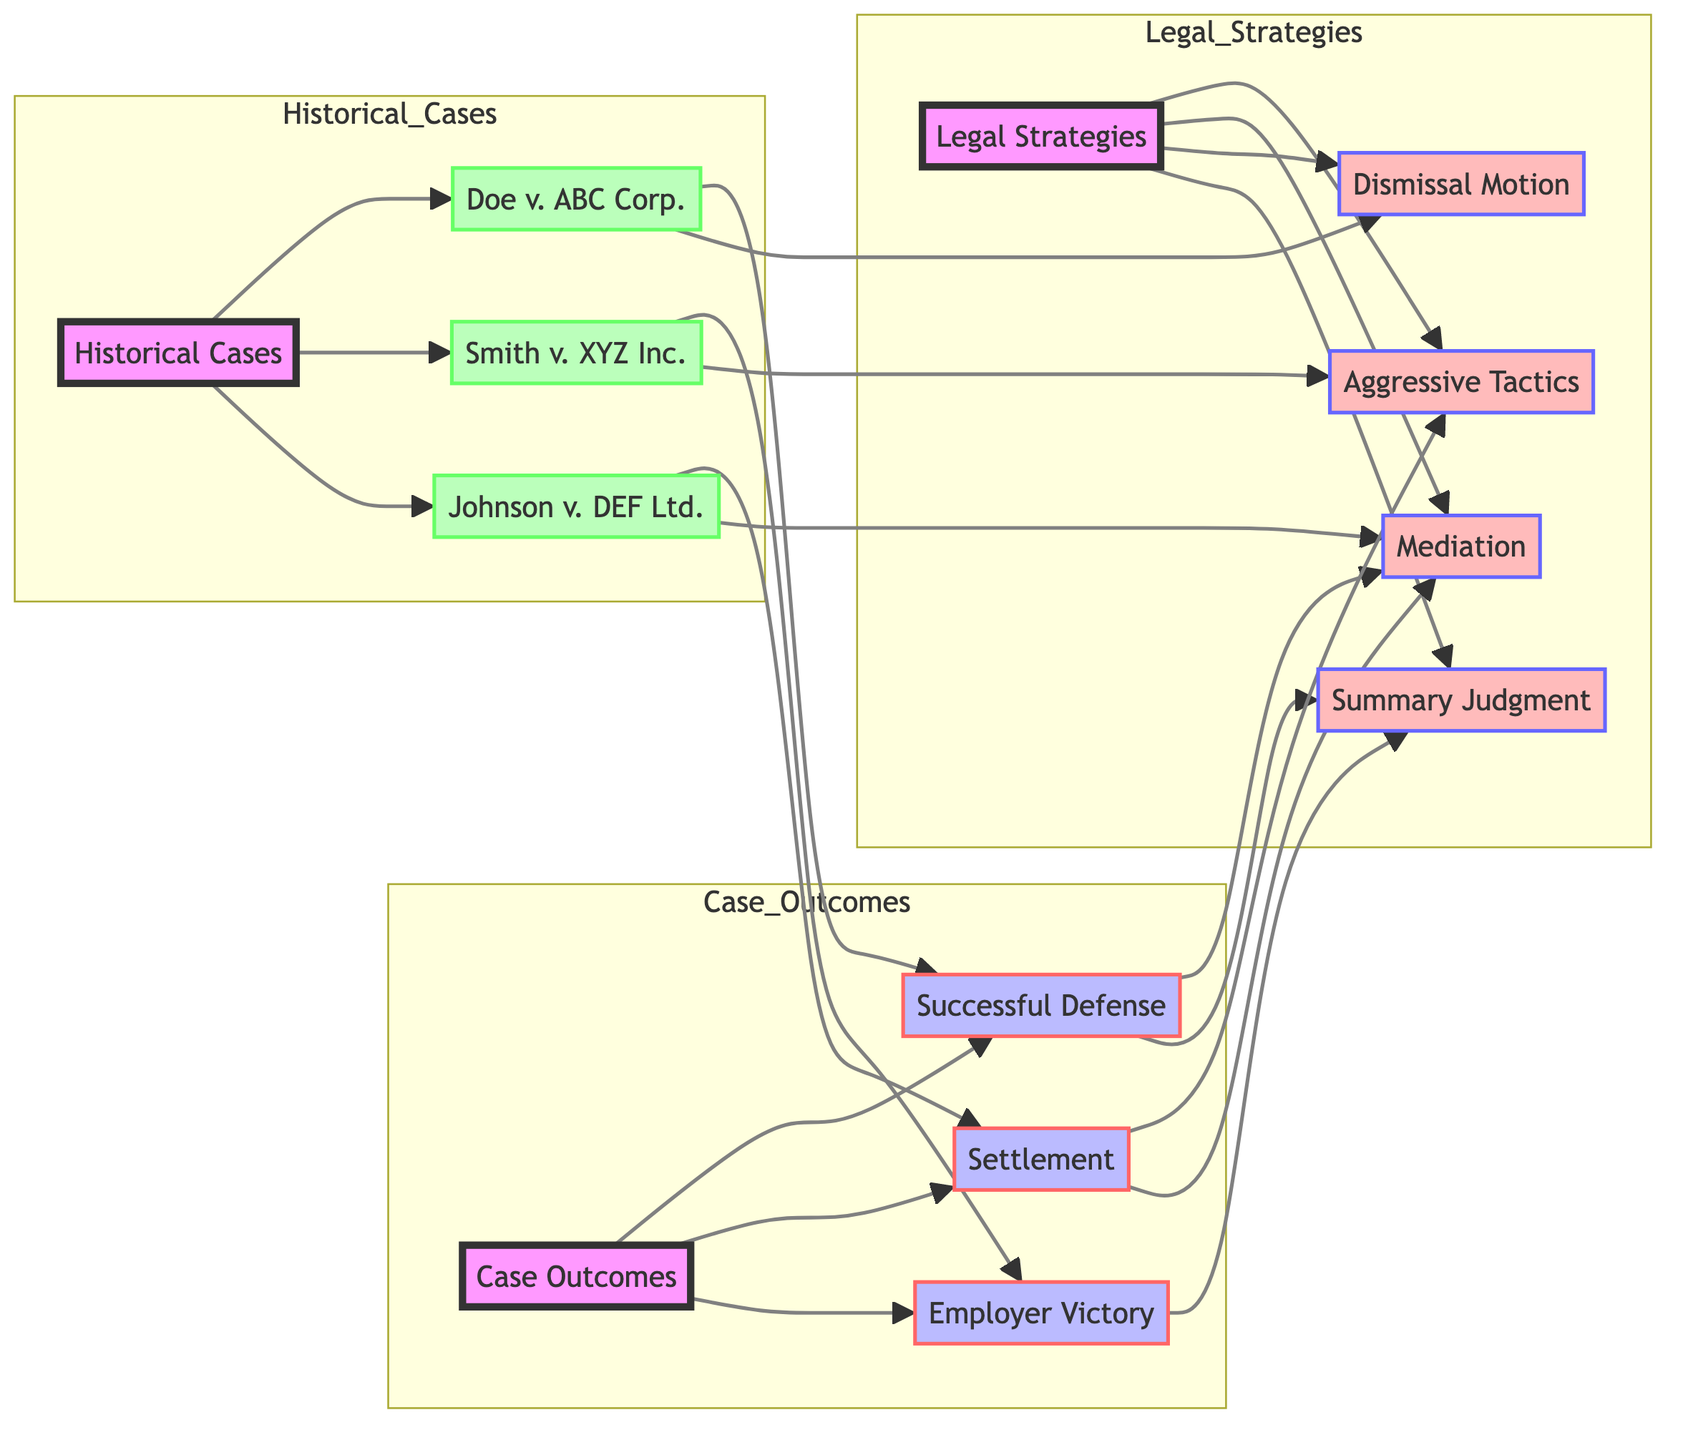What are the three case outcomes represented in the diagram? The diagram shows three case outcomes: Successful Defense, Settlement, and Employer Victory, all of which are part of the Case Outcomes category.
Answer: Successful Defense, Settlement, Employer Victory How many legal strategies are depicted in the network? There are four legal strategies shown in the diagram: Aggressive Tactics, Mediation, Dismissal Motion, and Summary Judgment under the Legal Strategies category, making a total of four.
Answer: 4 Which case resulted in a Settlement? The case Johnson v. DEF Ltd. resulted in a Settlement, as indicated by the direction from the case node to the case outcome node.
Answer: Johnson v. DEF Ltd Which strategies are employed in the case Doe v. ABC Corp.? The case Doe v. ABC Corp. employed the Dismissal Motion strategy, as shown by the direct link between the case node and the strategy node.
Answer: Dismissal Motion What legal strategy is associated with Successful Defense? Successful Defense is associated with both Mediation and Summary Judgment strategies, providing pathways from Successful Defense to these strategies in the diagram.
Answer: Mediation, Summary Judgment How many edges connect the Case Outcomes to the outcomes listed? There are three edges that connect the Case Outcomes category to the outcomes listed: Successful Defense, Settlement, and Employer Victory, meaning three direct connections.
Answer: 3 Which historical case employed Aggressive Tactics? The historical case Smith v. XYZ Inc. employed Aggressive Tactics as indicated by the link from this case to the strategy node for Aggressive Tactics.
Answer: Smith v. XYZ Inc What type of relationship exists between Settlement and Aggressive Tactics? The relationship between Settlement and Aggressive Tactics is classified as "associated_with," indicating a link connecting the two concepts in the diagram.
Answer: associated_with Which two case outcomes are associated with the Summary Judgment strategy? Summary Judgment strategy is associated with both Successful Defense and Employer Victory case outcomes, demonstrating a connection from the strategy to each outcome node.
Answer: Successful Defense, Employer Victory 